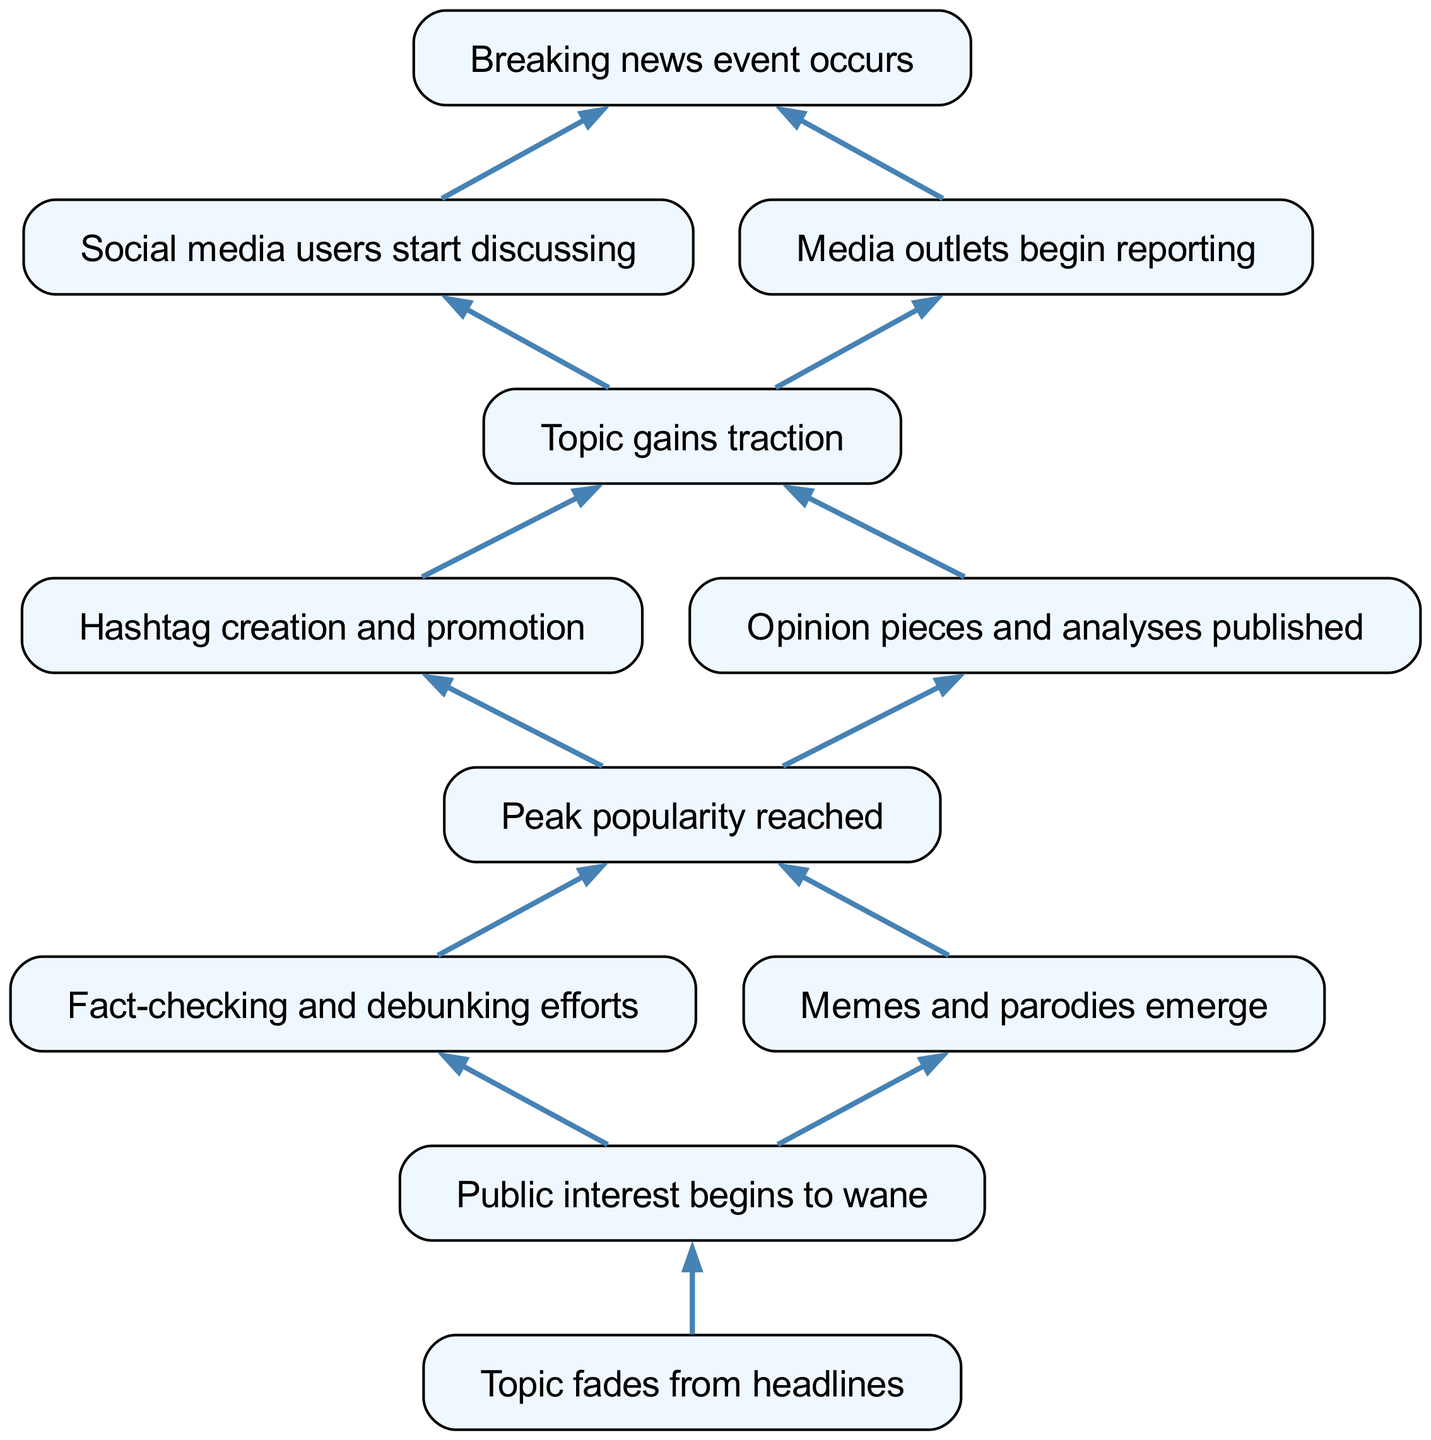What triggers the discussion of a trending topic? The diagram indicates that the discussion begins when a breaking news event occurs, as this is the initial step in the flow chart. Therefore, the first node directly leading to discussions is the breaking news event.
Answer: Breaking news event occurs How many connections does the topic gaining traction have? In the diagram, the node "Topic gains traction" has two connections leading to "Hashtag creation and promotion" and "Opinion pieces and analyses published." This count can be visually verified by examining the connections from the node.
Answer: 2 What follows the peak popularity of a topic? The diagram shows that following "Peak popularity reached," there are two pathways: one leading to "Fact-checking and debunking efforts" and another to "Memes and parodies emerge." Thus, the next steps after peak popularity are these two activities.
Answer: Fact-checking and debunking efforts and Memes and parodies emerge Which element follows the decline in public interest? According to the flow of the diagram, after the node "Public interest begins to wane," the next logical step is that "Topic fades from headlines," indicating how the decline manifests in the public eye and media coverage.
Answer: Topic fades from headlines What is the first step in the lifecycle of a trending topic? The diagram clearly marks the starting point of the lifecycle as the occurrence of a breaking news event, which initiates further discussions and media reports, creating a sequence leading to eventually trending topics.
Answer: Breaking news event occurs What happens after social media users start discussing the topic? After "Social media users start discussing," both "Topic gains traction" and "Media outlets begin reporting" are subsequent nodes that stem from this discussion, indicating that social media discussions often spark media coverage and wider interest.
Answer: Topic gains traction and Media outlets begin reporting How many total nodes are in the diagram? By counting the nodes visually represented in the diagram, there are eleven distinct elements that track the lifecycle phases of a trending topic, from emergence to decline.
Answer: 11 What is the purpose of hashtags during the topic's lifecycle? In the context of the diagram, "Hashtag creation and promotion" serves as a means for enhancing visibility and engagement with the topic, thus playing a crucial role in how trends gain traction during their lifecycle.
Answer: Enhance visibility and engagement 